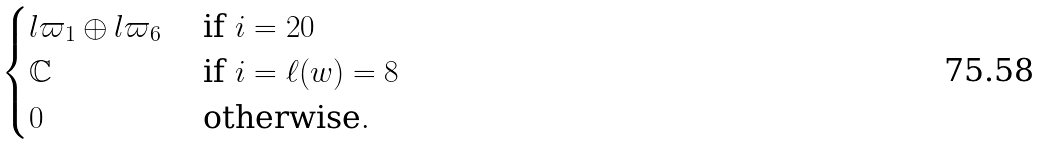Convert formula to latex. <formula><loc_0><loc_0><loc_500><loc_500>\begin{cases} l \varpi _ { 1 } \oplus l \varpi _ { 6 } & \text { if } i = 2 0 \\ { \mathbb { C } } & \text { if } i = \ell ( w ) = 8 \\ 0 & \text { otherwise} . \end{cases}</formula> 